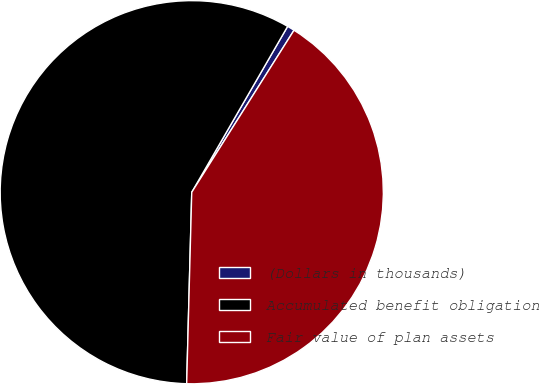Convert chart to OTSL. <chart><loc_0><loc_0><loc_500><loc_500><pie_chart><fcel>(Dollars in thousands)<fcel>Accumulated benefit obligation<fcel>Fair value of plan assets<nl><fcel>0.62%<fcel>57.92%<fcel>41.46%<nl></chart> 